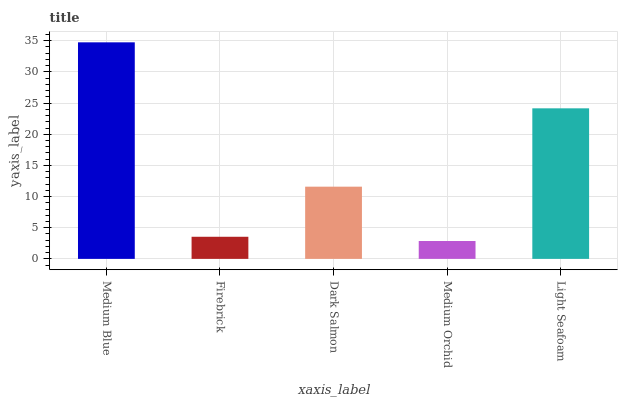Is Firebrick the minimum?
Answer yes or no. No. Is Firebrick the maximum?
Answer yes or no. No. Is Medium Blue greater than Firebrick?
Answer yes or no. Yes. Is Firebrick less than Medium Blue?
Answer yes or no. Yes. Is Firebrick greater than Medium Blue?
Answer yes or no. No. Is Medium Blue less than Firebrick?
Answer yes or no. No. Is Dark Salmon the high median?
Answer yes or no. Yes. Is Dark Salmon the low median?
Answer yes or no. Yes. Is Medium Blue the high median?
Answer yes or no. No. Is Medium Blue the low median?
Answer yes or no. No. 